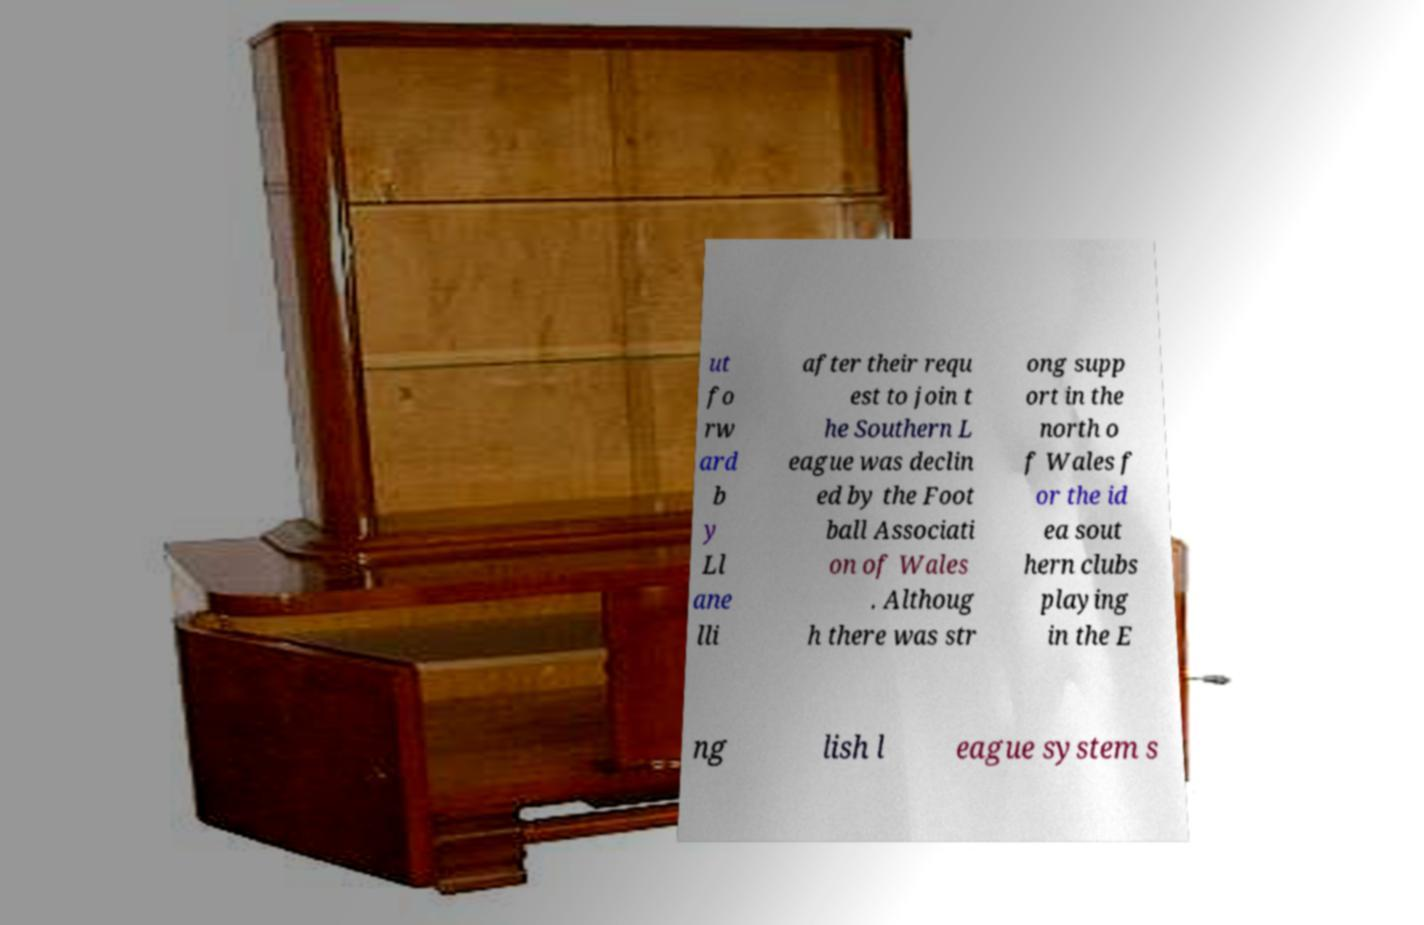Could you assist in decoding the text presented in this image and type it out clearly? ut fo rw ard b y Ll ane lli after their requ est to join t he Southern L eague was declin ed by the Foot ball Associati on of Wales . Althoug h there was str ong supp ort in the north o f Wales f or the id ea sout hern clubs playing in the E ng lish l eague system s 